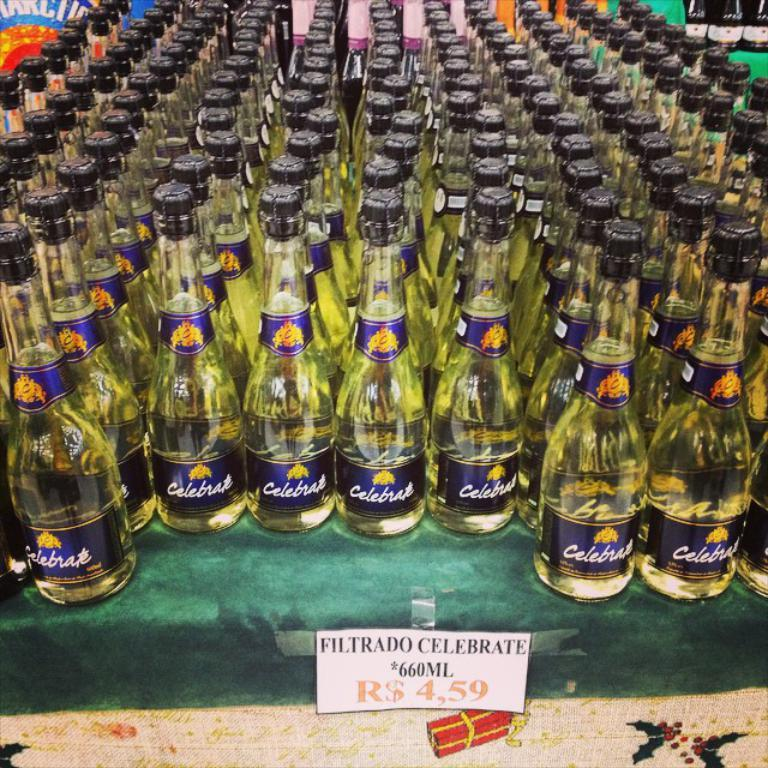Provide a one-sentence caption for the provided image. an entire table of filtrado celebrate is for sale. 